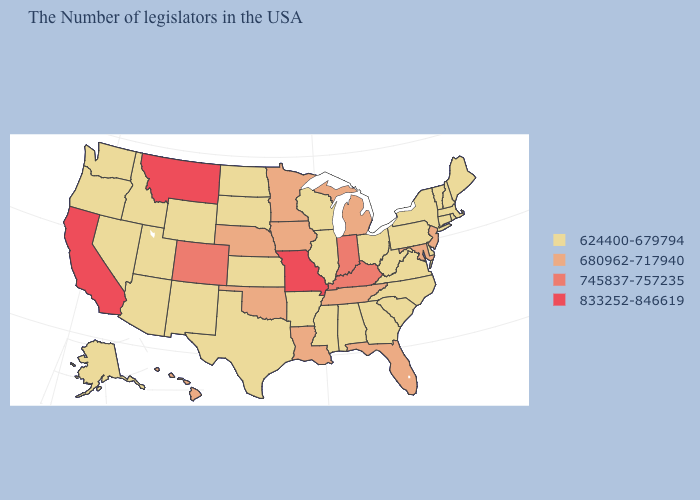Name the states that have a value in the range 833252-846619?
Concise answer only. Missouri, Montana, California. Does North Carolina have the same value as Rhode Island?
Quick response, please. Yes. Does Kentucky have the highest value in the South?
Keep it brief. Yes. Which states have the highest value in the USA?
Be succinct. Missouri, Montana, California. Is the legend a continuous bar?
Be succinct. No. What is the value of Oregon?
Keep it brief. 624400-679794. Name the states that have a value in the range 745837-757235?
Give a very brief answer. Kentucky, Indiana, Colorado. Name the states that have a value in the range 680962-717940?
Quick response, please. New Jersey, Maryland, Florida, Michigan, Tennessee, Louisiana, Minnesota, Iowa, Nebraska, Oklahoma, Hawaii. Does Idaho have a lower value than Alaska?
Be succinct. No. Is the legend a continuous bar?
Give a very brief answer. No. What is the lowest value in the USA?
Short answer required. 624400-679794. Name the states that have a value in the range 833252-846619?
Quick response, please. Missouri, Montana, California. What is the lowest value in the USA?
Give a very brief answer. 624400-679794. What is the value of Indiana?
Be succinct. 745837-757235. 